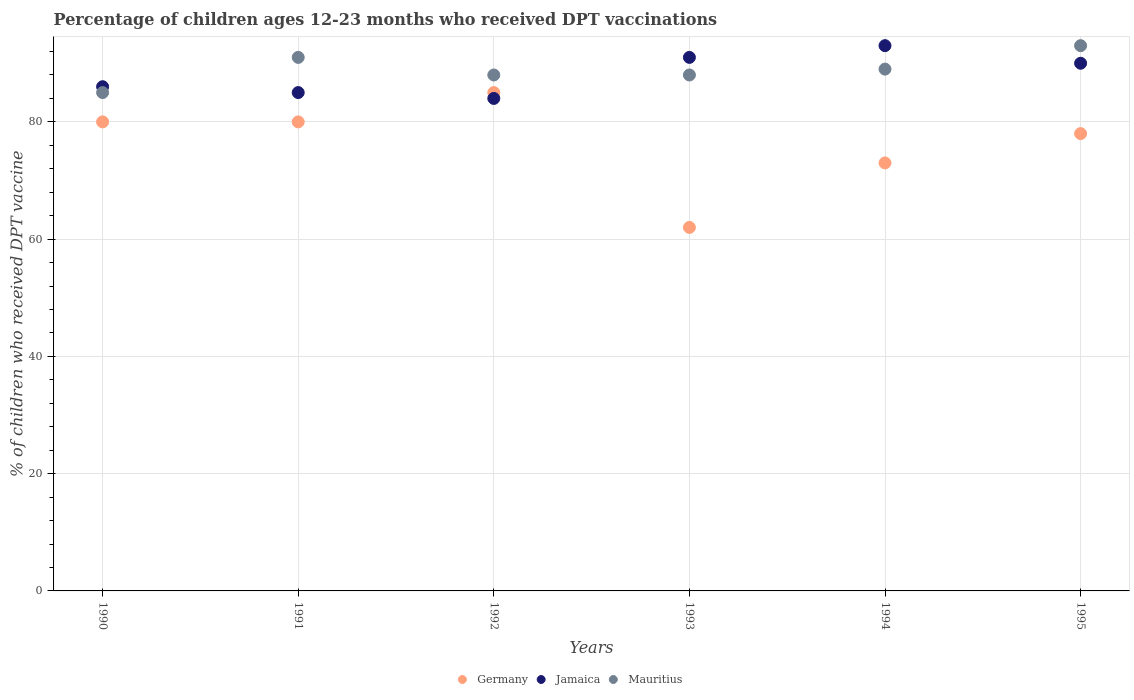How many different coloured dotlines are there?
Make the answer very short. 3. Is the number of dotlines equal to the number of legend labels?
Your answer should be compact. Yes. What is the percentage of children who received DPT vaccination in Jamaica in 1993?
Give a very brief answer. 91. Across all years, what is the maximum percentage of children who received DPT vaccination in Jamaica?
Offer a terse response. 93. Across all years, what is the minimum percentage of children who received DPT vaccination in Germany?
Your response must be concise. 62. In which year was the percentage of children who received DPT vaccination in Mauritius maximum?
Give a very brief answer. 1995. In which year was the percentage of children who received DPT vaccination in Germany minimum?
Keep it short and to the point. 1993. What is the total percentage of children who received DPT vaccination in Germany in the graph?
Offer a terse response. 458. What is the difference between the percentage of children who received DPT vaccination in Mauritius in 1993 and that in 1994?
Your response must be concise. -1. What is the difference between the percentage of children who received DPT vaccination in Germany in 1991 and the percentage of children who received DPT vaccination in Jamaica in 1995?
Offer a very short reply. -10. What is the average percentage of children who received DPT vaccination in Jamaica per year?
Provide a succinct answer. 88.17. In how many years, is the percentage of children who received DPT vaccination in Germany greater than 40 %?
Offer a terse response. 6. What is the ratio of the percentage of children who received DPT vaccination in Germany in 1991 to that in 1993?
Offer a very short reply. 1.29. Is the difference between the percentage of children who received DPT vaccination in Mauritius in 1990 and 1993 greater than the difference between the percentage of children who received DPT vaccination in Germany in 1990 and 1993?
Offer a terse response. No. What is the difference between the highest and the lowest percentage of children who received DPT vaccination in Jamaica?
Your answer should be compact. 9. In how many years, is the percentage of children who received DPT vaccination in Germany greater than the average percentage of children who received DPT vaccination in Germany taken over all years?
Make the answer very short. 4. Is the sum of the percentage of children who received DPT vaccination in Mauritius in 1992 and 1994 greater than the maximum percentage of children who received DPT vaccination in Jamaica across all years?
Offer a very short reply. Yes. Is it the case that in every year, the sum of the percentage of children who received DPT vaccination in Mauritius and percentage of children who received DPT vaccination in Jamaica  is greater than the percentage of children who received DPT vaccination in Germany?
Ensure brevity in your answer.  Yes. Is the percentage of children who received DPT vaccination in Mauritius strictly less than the percentage of children who received DPT vaccination in Jamaica over the years?
Ensure brevity in your answer.  No. What is the difference between two consecutive major ticks on the Y-axis?
Offer a very short reply. 20. Does the graph contain grids?
Your answer should be compact. Yes. What is the title of the graph?
Make the answer very short. Percentage of children ages 12-23 months who received DPT vaccinations. Does "West Bank and Gaza" appear as one of the legend labels in the graph?
Give a very brief answer. No. What is the label or title of the X-axis?
Offer a very short reply. Years. What is the label or title of the Y-axis?
Keep it short and to the point. % of children who received DPT vaccine. What is the % of children who received DPT vaccine of Jamaica in 1990?
Your response must be concise. 86. What is the % of children who received DPT vaccine of Mauritius in 1990?
Offer a very short reply. 85. What is the % of children who received DPT vaccine of Germany in 1991?
Give a very brief answer. 80. What is the % of children who received DPT vaccine in Jamaica in 1991?
Keep it short and to the point. 85. What is the % of children who received DPT vaccine of Mauritius in 1991?
Keep it short and to the point. 91. What is the % of children who received DPT vaccine in Germany in 1992?
Your answer should be compact. 85. What is the % of children who received DPT vaccine of Jamaica in 1992?
Ensure brevity in your answer.  84. What is the % of children who received DPT vaccine in Germany in 1993?
Provide a short and direct response. 62. What is the % of children who received DPT vaccine in Jamaica in 1993?
Ensure brevity in your answer.  91. What is the % of children who received DPT vaccine of Germany in 1994?
Offer a very short reply. 73. What is the % of children who received DPT vaccine in Jamaica in 1994?
Keep it short and to the point. 93. What is the % of children who received DPT vaccine of Mauritius in 1994?
Provide a short and direct response. 89. What is the % of children who received DPT vaccine in Jamaica in 1995?
Ensure brevity in your answer.  90. What is the % of children who received DPT vaccine in Mauritius in 1995?
Your answer should be compact. 93. Across all years, what is the maximum % of children who received DPT vaccine of Jamaica?
Your answer should be very brief. 93. Across all years, what is the maximum % of children who received DPT vaccine of Mauritius?
Your answer should be very brief. 93. Across all years, what is the minimum % of children who received DPT vaccine in Jamaica?
Offer a terse response. 84. What is the total % of children who received DPT vaccine in Germany in the graph?
Keep it short and to the point. 458. What is the total % of children who received DPT vaccine of Jamaica in the graph?
Provide a short and direct response. 529. What is the total % of children who received DPT vaccine in Mauritius in the graph?
Your answer should be very brief. 534. What is the difference between the % of children who received DPT vaccine in Mauritius in 1990 and that in 1992?
Your answer should be very brief. -3. What is the difference between the % of children who received DPT vaccine of Germany in 1990 and that in 1994?
Your response must be concise. 7. What is the difference between the % of children who received DPT vaccine of Jamaica in 1990 and that in 1994?
Offer a very short reply. -7. What is the difference between the % of children who received DPT vaccine of Mauritius in 1990 and that in 1994?
Offer a very short reply. -4. What is the difference between the % of children who received DPT vaccine in Mauritius in 1990 and that in 1995?
Give a very brief answer. -8. What is the difference between the % of children who received DPT vaccine in Jamaica in 1991 and that in 1992?
Your answer should be compact. 1. What is the difference between the % of children who received DPT vaccine of Mauritius in 1991 and that in 1992?
Your answer should be compact. 3. What is the difference between the % of children who received DPT vaccine of Jamaica in 1991 and that in 1993?
Your answer should be compact. -6. What is the difference between the % of children who received DPT vaccine in Mauritius in 1991 and that in 1993?
Your answer should be very brief. 3. What is the difference between the % of children who received DPT vaccine in Jamaica in 1991 and that in 1994?
Your answer should be compact. -8. What is the difference between the % of children who received DPT vaccine in Mauritius in 1991 and that in 1994?
Provide a succinct answer. 2. What is the difference between the % of children who received DPT vaccine in Germany in 1991 and that in 1995?
Provide a succinct answer. 2. What is the difference between the % of children who received DPT vaccine in Jamaica in 1991 and that in 1995?
Your answer should be compact. -5. What is the difference between the % of children who received DPT vaccine in Jamaica in 1992 and that in 1993?
Provide a succinct answer. -7. What is the difference between the % of children who received DPT vaccine in Mauritius in 1992 and that in 1993?
Provide a succinct answer. 0. What is the difference between the % of children who received DPT vaccine of Germany in 1992 and that in 1994?
Your answer should be compact. 12. What is the difference between the % of children who received DPT vaccine of Mauritius in 1992 and that in 1994?
Your answer should be compact. -1. What is the difference between the % of children who received DPT vaccine in Germany in 1992 and that in 1995?
Give a very brief answer. 7. What is the difference between the % of children who received DPT vaccine of Jamaica in 1992 and that in 1995?
Offer a very short reply. -6. What is the difference between the % of children who received DPT vaccine in Germany in 1993 and that in 1994?
Make the answer very short. -11. What is the difference between the % of children who received DPT vaccine in Jamaica in 1993 and that in 1994?
Make the answer very short. -2. What is the difference between the % of children who received DPT vaccine of Germany in 1993 and that in 1995?
Your answer should be compact. -16. What is the difference between the % of children who received DPT vaccine of Germany in 1994 and that in 1995?
Your response must be concise. -5. What is the difference between the % of children who received DPT vaccine of Jamaica in 1994 and that in 1995?
Ensure brevity in your answer.  3. What is the difference between the % of children who received DPT vaccine of Mauritius in 1994 and that in 1995?
Keep it short and to the point. -4. What is the difference between the % of children who received DPT vaccine of Jamaica in 1990 and the % of children who received DPT vaccine of Mauritius in 1991?
Provide a succinct answer. -5. What is the difference between the % of children who received DPT vaccine of Germany in 1990 and the % of children who received DPT vaccine of Mauritius in 1992?
Your answer should be very brief. -8. What is the difference between the % of children who received DPT vaccine of Jamaica in 1990 and the % of children who received DPT vaccine of Mauritius in 1992?
Ensure brevity in your answer.  -2. What is the difference between the % of children who received DPT vaccine of Germany in 1990 and the % of children who received DPT vaccine of Jamaica in 1993?
Offer a terse response. -11. What is the difference between the % of children who received DPT vaccine in Germany in 1990 and the % of children who received DPT vaccine in Mauritius in 1993?
Your answer should be very brief. -8. What is the difference between the % of children who received DPT vaccine in Jamaica in 1990 and the % of children who received DPT vaccine in Mauritius in 1993?
Keep it short and to the point. -2. What is the difference between the % of children who received DPT vaccine of Jamaica in 1990 and the % of children who received DPT vaccine of Mauritius in 1994?
Your answer should be compact. -3. What is the difference between the % of children who received DPT vaccine of Jamaica in 1990 and the % of children who received DPT vaccine of Mauritius in 1995?
Offer a very short reply. -7. What is the difference between the % of children who received DPT vaccine of Germany in 1991 and the % of children who received DPT vaccine of Jamaica in 1992?
Provide a succinct answer. -4. What is the difference between the % of children who received DPT vaccine of Germany in 1991 and the % of children who received DPT vaccine of Mauritius in 1992?
Provide a succinct answer. -8. What is the difference between the % of children who received DPT vaccine of Germany in 1991 and the % of children who received DPT vaccine of Jamaica in 1993?
Provide a succinct answer. -11. What is the difference between the % of children who received DPT vaccine of Germany in 1991 and the % of children who received DPT vaccine of Mauritius in 1993?
Keep it short and to the point. -8. What is the difference between the % of children who received DPT vaccine of Germany in 1991 and the % of children who received DPT vaccine of Jamaica in 1994?
Keep it short and to the point. -13. What is the difference between the % of children who received DPT vaccine in Germany in 1991 and the % of children who received DPT vaccine in Mauritius in 1995?
Your response must be concise. -13. What is the difference between the % of children who received DPT vaccine of Germany in 1992 and the % of children who received DPT vaccine of Jamaica in 1993?
Offer a very short reply. -6. What is the difference between the % of children who received DPT vaccine in Germany in 1992 and the % of children who received DPT vaccine in Mauritius in 1994?
Provide a short and direct response. -4. What is the difference between the % of children who received DPT vaccine in Germany in 1992 and the % of children who received DPT vaccine in Mauritius in 1995?
Offer a very short reply. -8. What is the difference between the % of children who received DPT vaccine in Jamaica in 1992 and the % of children who received DPT vaccine in Mauritius in 1995?
Your answer should be very brief. -9. What is the difference between the % of children who received DPT vaccine of Germany in 1993 and the % of children who received DPT vaccine of Jamaica in 1994?
Ensure brevity in your answer.  -31. What is the difference between the % of children who received DPT vaccine in Germany in 1993 and the % of children who received DPT vaccine in Mauritius in 1995?
Your answer should be compact. -31. What is the difference between the % of children who received DPT vaccine of Germany in 1994 and the % of children who received DPT vaccine of Mauritius in 1995?
Your answer should be very brief. -20. What is the average % of children who received DPT vaccine of Germany per year?
Keep it short and to the point. 76.33. What is the average % of children who received DPT vaccine in Jamaica per year?
Provide a succinct answer. 88.17. What is the average % of children who received DPT vaccine in Mauritius per year?
Keep it short and to the point. 89. In the year 1990, what is the difference between the % of children who received DPT vaccine of Germany and % of children who received DPT vaccine of Mauritius?
Give a very brief answer. -5. In the year 1991, what is the difference between the % of children who received DPT vaccine of Germany and % of children who received DPT vaccine of Jamaica?
Provide a succinct answer. -5. In the year 1991, what is the difference between the % of children who received DPT vaccine in Jamaica and % of children who received DPT vaccine in Mauritius?
Give a very brief answer. -6. In the year 1992, what is the difference between the % of children who received DPT vaccine of Germany and % of children who received DPT vaccine of Mauritius?
Provide a succinct answer. -3. In the year 1993, what is the difference between the % of children who received DPT vaccine of Germany and % of children who received DPT vaccine of Jamaica?
Your response must be concise. -29. In the year 1994, what is the difference between the % of children who received DPT vaccine of Germany and % of children who received DPT vaccine of Jamaica?
Keep it short and to the point. -20. In the year 1995, what is the difference between the % of children who received DPT vaccine of Germany and % of children who received DPT vaccine of Mauritius?
Your response must be concise. -15. In the year 1995, what is the difference between the % of children who received DPT vaccine of Jamaica and % of children who received DPT vaccine of Mauritius?
Your answer should be very brief. -3. What is the ratio of the % of children who received DPT vaccine of Jamaica in 1990 to that in 1991?
Your answer should be very brief. 1.01. What is the ratio of the % of children who received DPT vaccine of Mauritius in 1990 to that in 1991?
Your answer should be compact. 0.93. What is the ratio of the % of children who received DPT vaccine in Germany in 1990 to that in 1992?
Give a very brief answer. 0.94. What is the ratio of the % of children who received DPT vaccine of Jamaica in 1990 to that in 1992?
Your response must be concise. 1.02. What is the ratio of the % of children who received DPT vaccine in Mauritius in 1990 to that in 1992?
Your answer should be very brief. 0.97. What is the ratio of the % of children who received DPT vaccine of Germany in 1990 to that in 1993?
Make the answer very short. 1.29. What is the ratio of the % of children who received DPT vaccine of Jamaica in 1990 to that in 1993?
Provide a succinct answer. 0.95. What is the ratio of the % of children who received DPT vaccine in Mauritius in 1990 to that in 1993?
Keep it short and to the point. 0.97. What is the ratio of the % of children who received DPT vaccine of Germany in 1990 to that in 1994?
Your answer should be very brief. 1.1. What is the ratio of the % of children who received DPT vaccine of Jamaica in 1990 to that in 1994?
Ensure brevity in your answer.  0.92. What is the ratio of the % of children who received DPT vaccine of Mauritius in 1990 to that in 1994?
Give a very brief answer. 0.96. What is the ratio of the % of children who received DPT vaccine of Germany in 1990 to that in 1995?
Keep it short and to the point. 1.03. What is the ratio of the % of children who received DPT vaccine of Jamaica in 1990 to that in 1995?
Offer a very short reply. 0.96. What is the ratio of the % of children who received DPT vaccine of Mauritius in 1990 to that in 1995?
Provide a succinct answer. 0.91. What is the ratio of the % of children who received DPT vaccine in Jamaica in 1991 to that in 1992?
Offer a terse response. 1.01. What is the ratio of the % of children who received DPT vaccine in Mauritius in 1991 to that in 1992?
Make the answer very short. 1.03. What is the ratio of the % of children who received DPT vaccine of Germany in 1991 to that in 1993?
Your answer should be compact. 1.29. What is the ratio of the % of children who received DPT vaccine of Jamaica in 1991 to that in 1993?
Provide a short and direct response. 0.93. What is the ratio of the % of children who received DPT vaccine in Mauritius in 1991 to that in 1993?
Your answer should be compact. 1.03. What is the ratio of the % of children who received DPT vaccine of Germany in 1991 to that in 1994?
Make the answer very short. 1.1. What is the ratio of the % of children who received DPT vaccine in Jamaica in 1991 to that in 1994?
Give a very brief answer. 0.91. What is the ratio of the % of children who received DPT vaccine in Mauritius in 1991 to that in 1994?
Provide a short and direct response. 1.02. What is the ratio of the % of children who received DPT vaccine of Germany in 1991 to that in 1995?
Give a very brief answer. 1.03. What is the ratio of the % of children who received DPT vaccine of Jamaica in 1991 to that in 1995?
Make the answer very short. 0.94. What is the ratio of the % of children who received DPT vaccine in Mauritius in 1991 to that in 1995?
Offer a terse response. 0.98. What is the ratio of the % of children who received DPT vaccine in Germany in 1992 to that in 1993?
Provide a short and direct response. 1.37. What is the ratio of the % of children who received DPT vaccine of Mauritius in 1992 to that in 1993?
Provide a succinct answer. 1. What is the ratio of the % of children who received DPT vaccine in Germany in 1992 to that in 1994?
Provide a succinct answer. 1.16. What is the ratio of the % of children who received DPT vaccine of Jamaica in 1992 to that in 1994?
Ensure brevity in your answer.  0.9. What is the ratio of the % of children who received DPT vaccine of Mauritius in 1992 to that in 1994?
Keep it short and to the point. 0.99. What is the ratio of the % of children who received DPT vaccine in Germany in 1992 to that in 1995?
Your answer should be compact. 1.09. What is the ratio of the % of children who received DPT vaccine of Jamaica in 1992 to that in 1995?
Your response must be concise. 0.93. What is the ratio of the % of children who received DPT vaccine in Mauritius in 1992 to that in 1995?
Offer a terse response. 0.95. What is the ratio of the % of children who received DPT vaccine in Germany in 1993 to that in 1994?
Offer a very short reply. 0.85. What is the ratio of the % of children who received DPT vaccine of Jamaica in 1993 to that in 1994?
Provide a short and direct response. 0.98. What is the ratio of the % of children who received DPT vaccine of Mauritius in 1993 to that in 1994?
Offer a very short reply. 0.99. What is the ratio of the % of children who received DPT vaccine of Germany in 1993 to that in 1995?
Keep it short and to the point. 0.79. What is the ratio of the % of children who received DPT vaccine in Jamaica in 1993 to that in 1995?
Your response must be concise. 1.01. What is the ratio of the % of children who received DPT vaccine in Mauritius in 1993 to that in 1995?
Provide a succinct answer. 0.95. What is the ratio of the % of children who received DPT vaccine of Germany in 1994 to that in 1995?
Offer a very short reply. 0.94. What is the ratio of the % of children who received DPT vaccine in Jamaica in 1994 to that in 1995?
Give a very brief answer. 1.03. What is the ratio of the % of children who received DPT vaccine in Mauritius in 1994 to that in 1995?
Ensure brevity in your answer.  0.96. What is the difference between the highest and the second highest % of children who received DPT vaccine in Mauritius?
Your response must be concise. 2. What is the difference between the highest and the lowest % of children who received DPT vaccine of Germany?
Provide a succinct answer. 23. What is the difference between the highest and the lowest % of children who received DPT vaccine of Jamaica?
Ensure brevity in your answer.  9. What is the difference between the highest and the lowest % of children who received DPT vaccine in Mauritius?
Offer a very short reply. 8. 